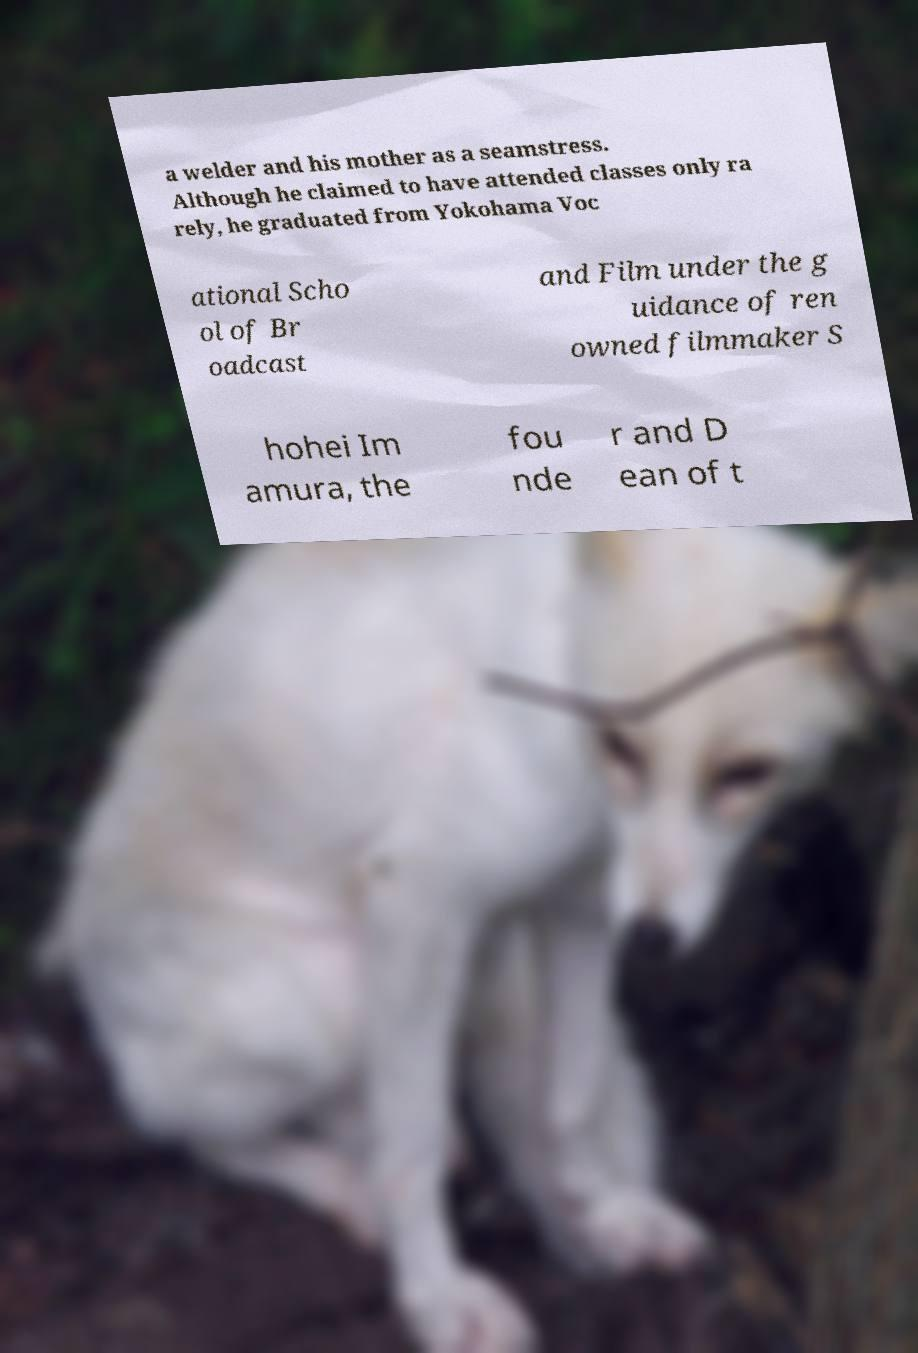For documentation purposes, I need the text within this image transcribed. Could you provide that? a welder and his mother as a seamstress. Although he claimed to have attended classes only ra rely, he graduated from Yokohama Voc ational Scho ol of Br oadcast and Film under the g uidance of ren owned filmmaker S hohei Im amura, the fou nde r and D ean of t 